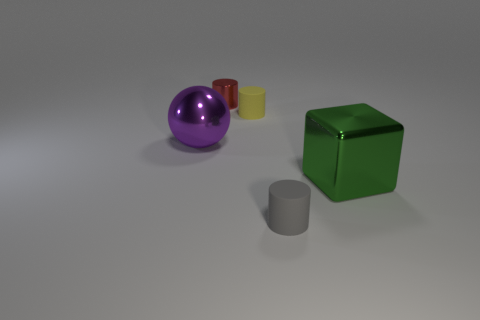There is a small object that is in front of the large thing that is to the right of the tiny cylinder to the left of the small yellow rubber object; what is its shape?
Your answer should be compact. Cylinder. What size is the green cube?
Offer a very short reply. Large. There is a big green thing that is made of the same material as the large purple ball; what shape is it?
Provide a succinct answer. Cube. Are there fewer small yellow things that are in front of the yellow matte cylinder than small red metal cylinders?
Give a very brief answer. Yes. What is the color of the big metal thing that is on the left side of the tiny yellow cylinder?
Keep it short and to the point. Purple. Are there any other big yellow objects of the same shape as the yellow object?
Give a very brief answer. No. How many small gray things have the same shape as the yellow object?
Offer a very short reply. 1. Is the color of the small metallic cylinder the same as the cube?
Offer a terse response. No. Are there fewer tiny purple cylinders than purple spheres?
Offer a terse response. Yes. There is a small cylinder that is in front of the yellow matte cylinder; what material is it?
Keep it short and to the point. Rubber. 